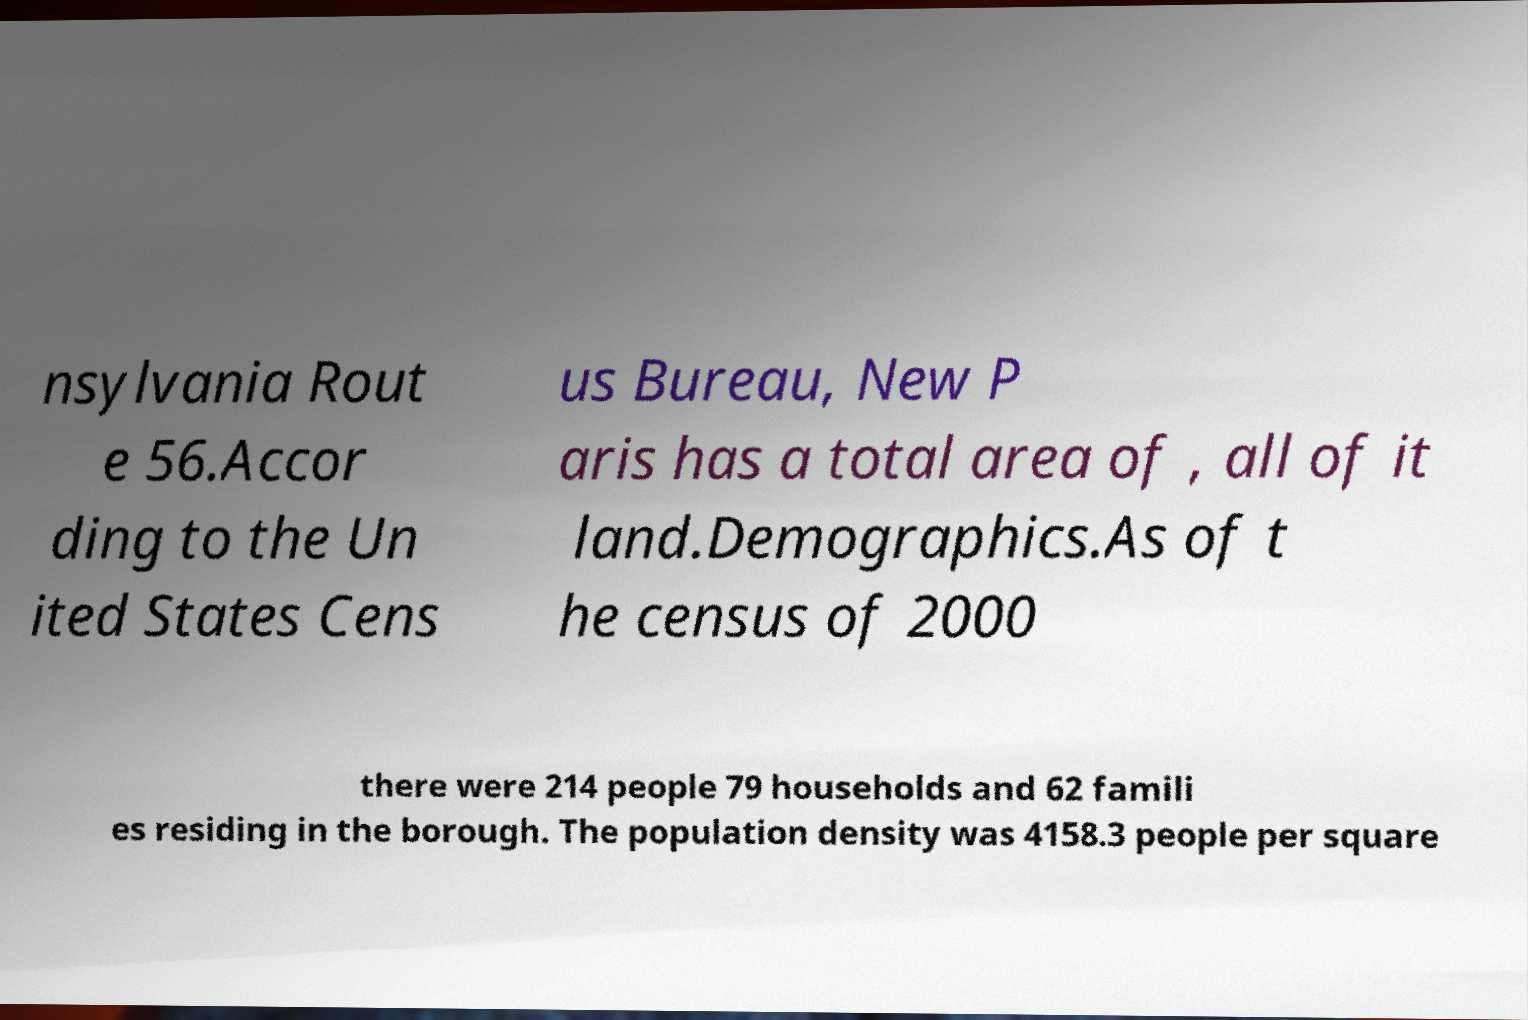I need the written content from this picture converted into text. Can you do that? nsylvania Rout e 56.Accor ding to the Un ited States Cens us Bureau, New P aris has a total area of , all of it land.Demographics.As of t he census of 2000 there were 214 people 79 households and 62 famili es residing in the borough. The population density was 4158.3 people per square 